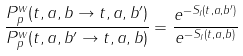Convert formula to latex. <formula><loc_0><loc_0><loc_500><loc_500>\frac { P _ { p } ^ { w } ( t , a , b \rightarrow t , a , b ^ { \prime } ) } { P _ { p } ^ { w } ( t , a , b ^ { \prime } \rightarrow t , a , b ) } = \frac { e ^ { - S _ { I } ( t , a , b ^ { \prime } ) } } { e ^ { - S _ { I } ( t , a , b ) } }</formula> 